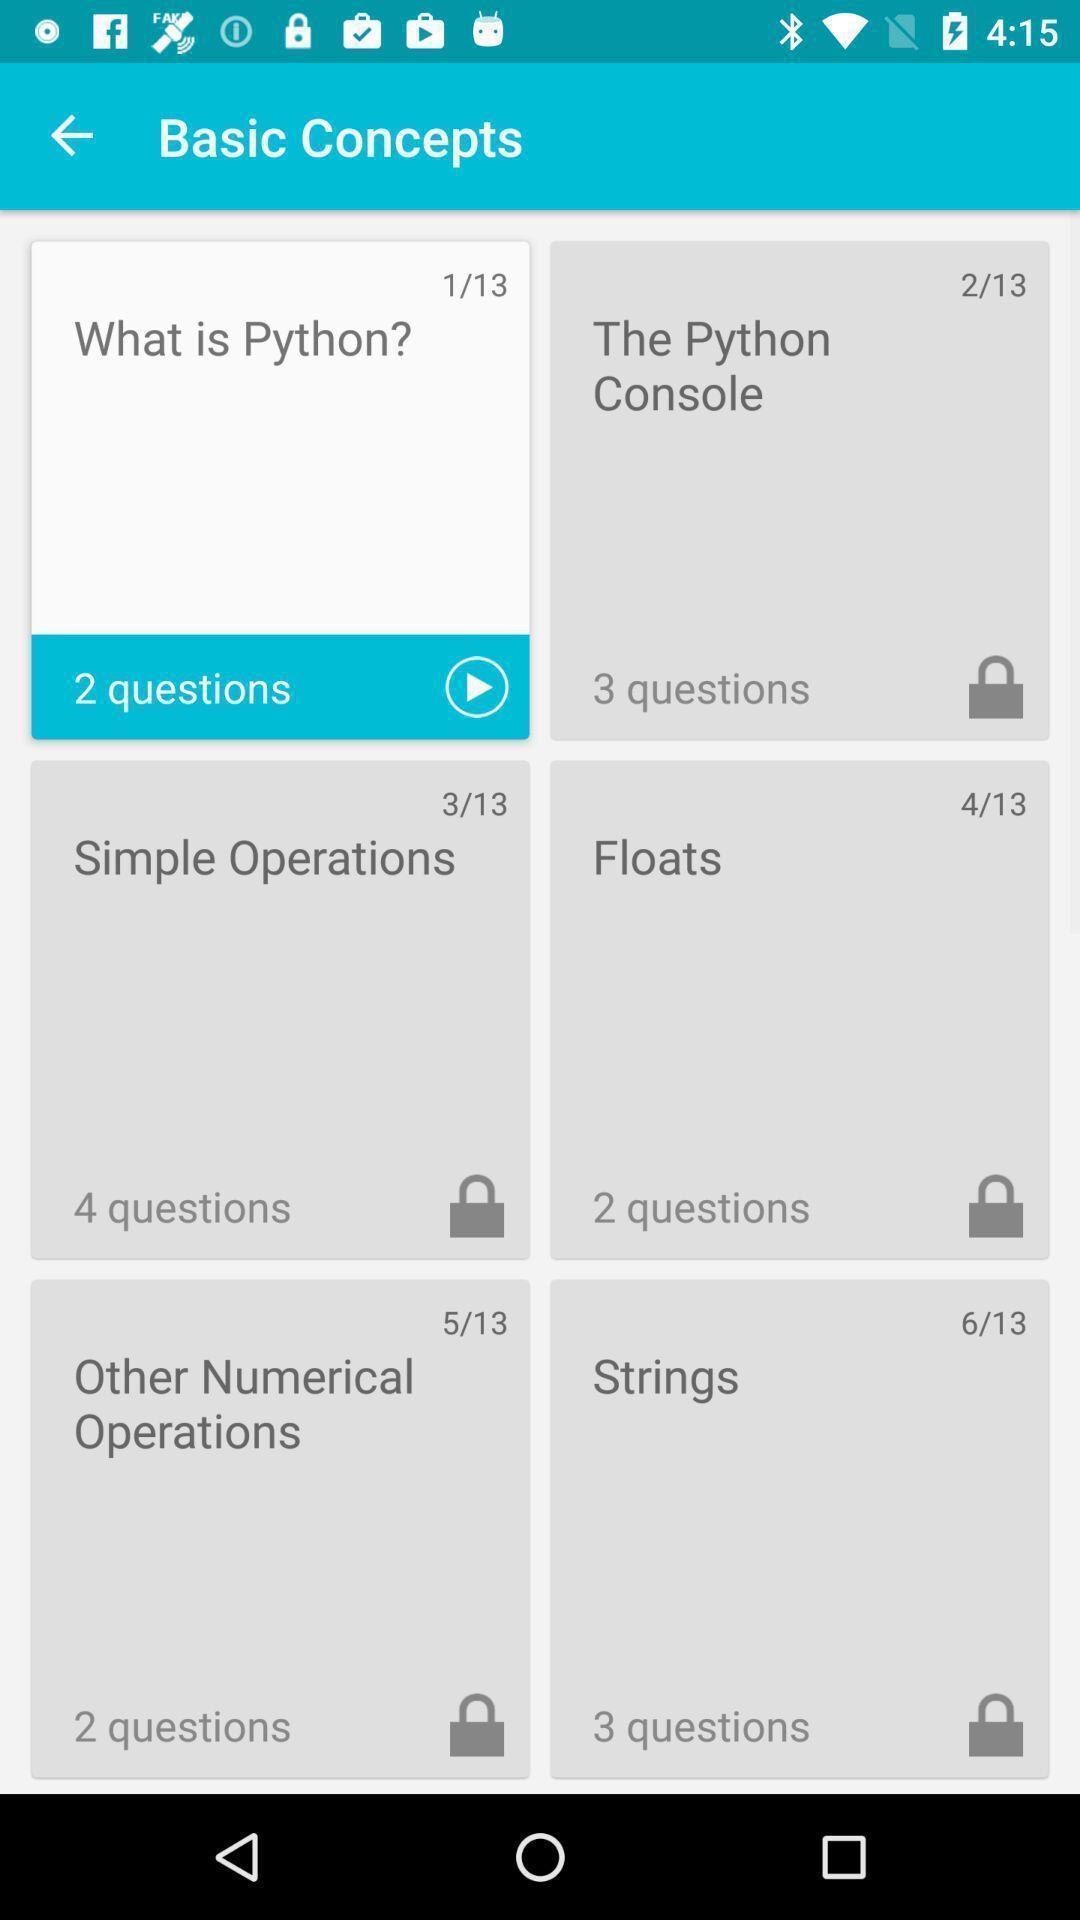Explain what's happening in this screen capture. Screen showing basic concepts in an learning application. 